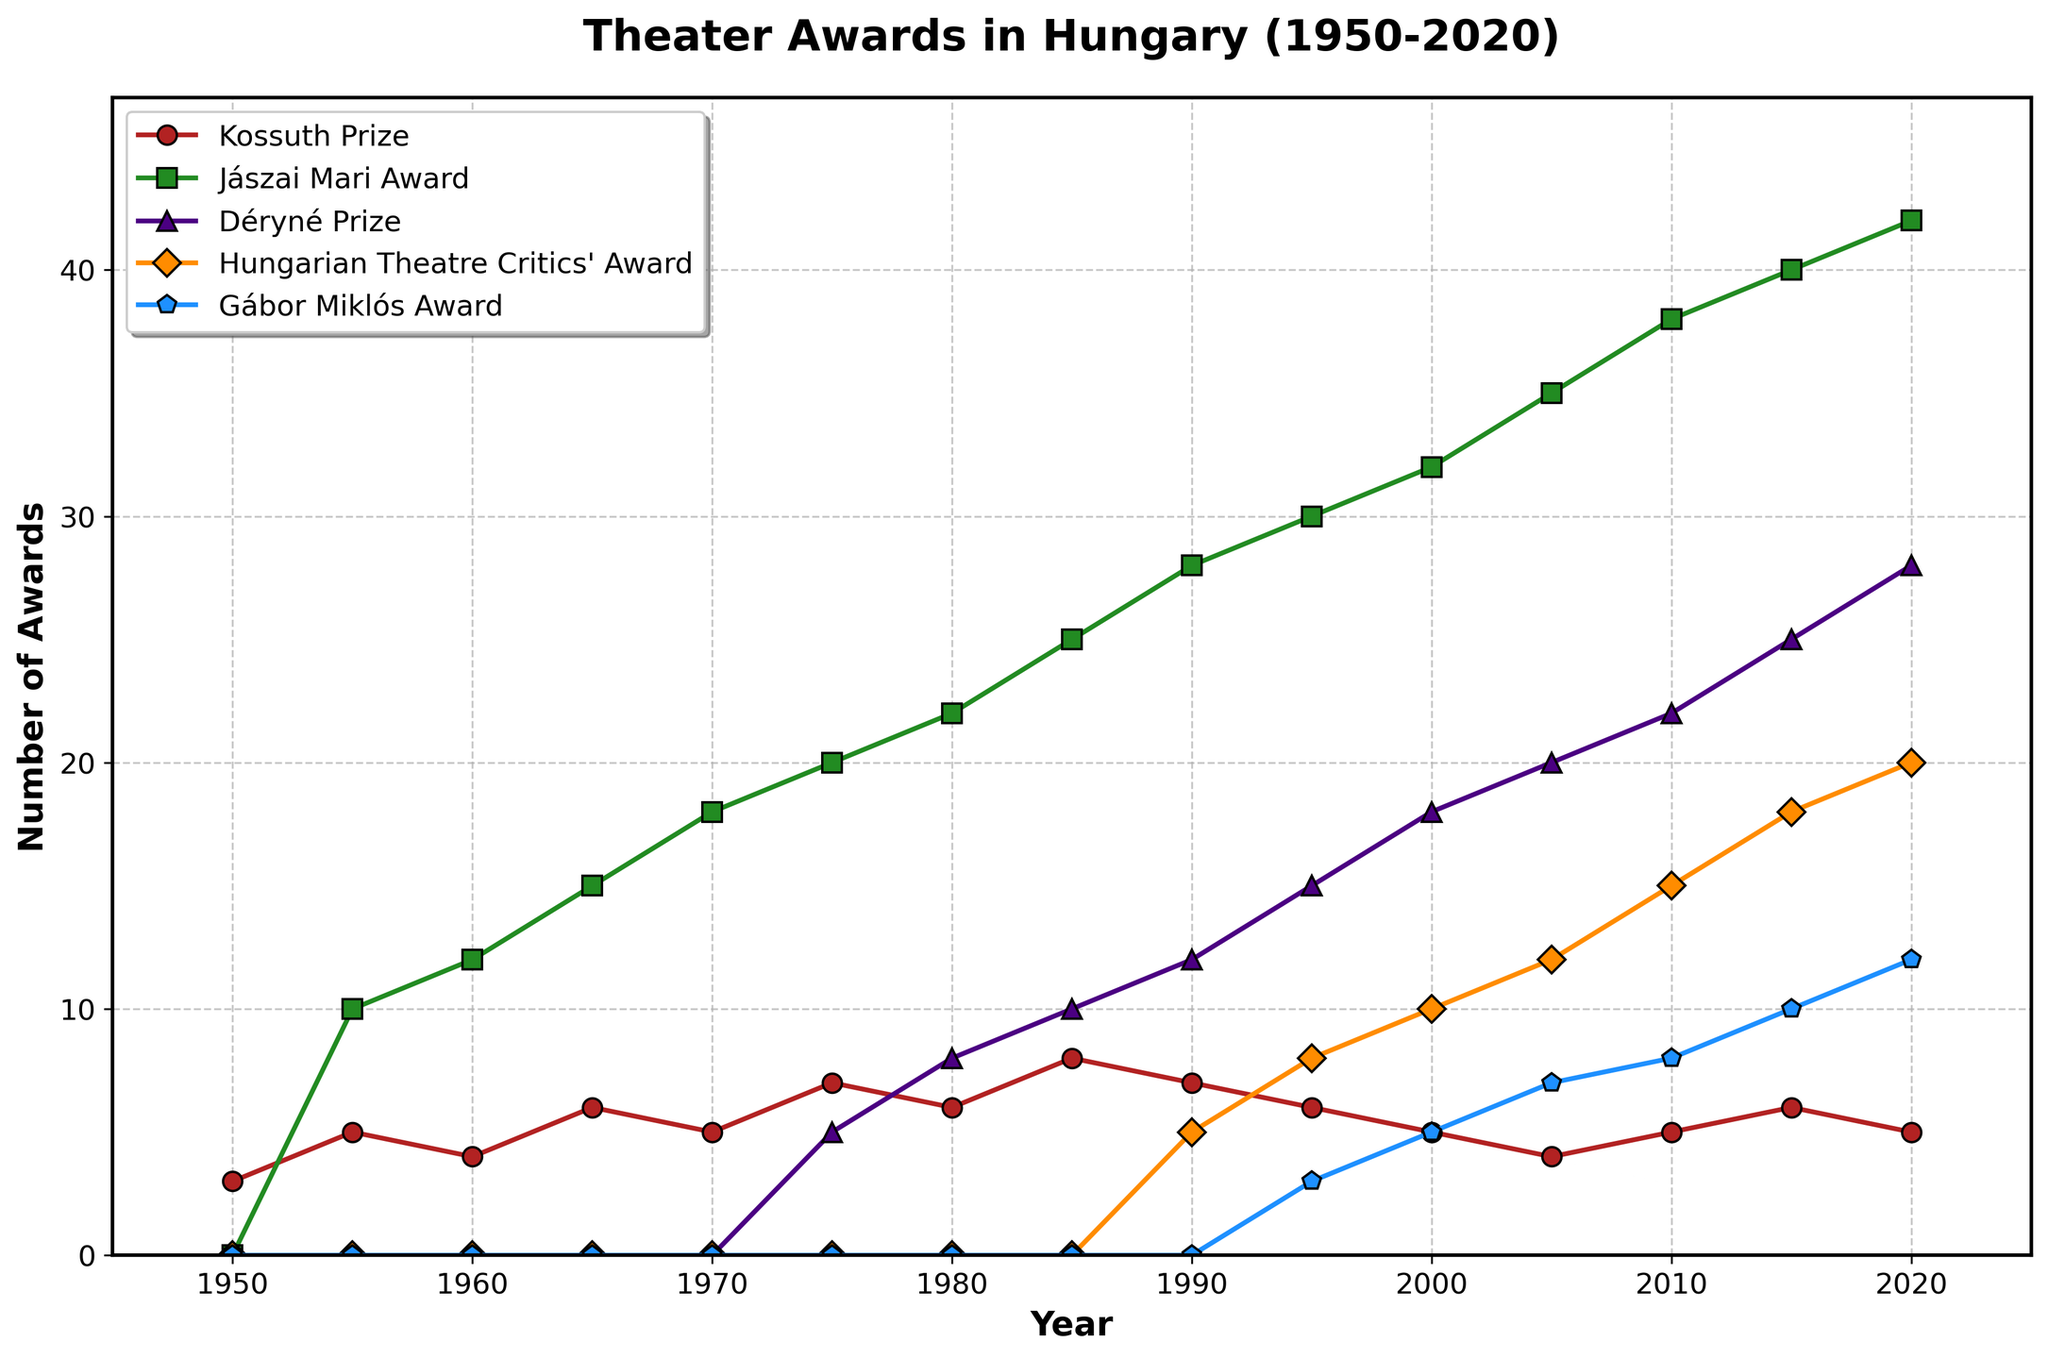What is the highest number of Kossuth Prizes given in a single year? To determine this, look at the line representing the Kossuth Prizes and identify the peak value on the y-axis. In this case, the highest value is reached in 1985 with 8 awards.
Answer: 8 Which award saw the most significant increase in the number of recipients between 1950 and 2020? To answer this, calculate the difference between the numbers in 2020 and 1950 for each award and compare these values. The largest increase is for the Jászai Mari Award, which went from 0 in 1950 to 42 in 2020.
Answer: Jászai Mari Award What year did the Hungarian Theatre Critics' Award start being given, and how many awards were given that year? Look for the first non-zero value for the Hungarian Theatre Critics' Award. In the plot, the award first appears in 1990, with 5 awards given.
Answer: 1990, 5 How many Déryné Prizes in total were awarded between 1975 and 2020? Sum the values of the Déryné Prizes for the years between 1975 and 2020. Adding these values (1975: 5, 1980: 8, 1985: 10, 1990: 12, 1995: 15, 2000: 18, 2005: 20, 2010: 22, 2015: 25, 2020: 28) gives a total of 163.
Answer: 163 Compare the trends of the Jászai Mari Award and the Kossuth Prize over the period. Which one shows a more steady increase? To determine the steadiness, look at the overall shape of both lines. The Jászai Mari Award shows a more consistent, linear increase from 1950 to 2020, while the Kossuth Prize has fluctuations.
Answer: Jászai Mari Award In what time period did the number of Gábor Miklós Awards see the most consistent growth? Look at the slope of the line representing the Gábor Miklós Award. The most consistent growth period is between 1995 and 2020, where it follows a steady upward trend from 0 to 12.
Answer: 1995-2020 What was the total number of awards given in 2015 across all categories? Add the number of awards given in each category for the year 2015 (Kossuth Prize: 6, Jászai Mari Award: 40, Déryné Prize: 25, Hungarian Theatre Critics' Award: 18, Gábor Miklós Award: 10). The total is 99.
Answer: 99 Which award seems to fluctuate the least over the years, indicating more consistent numbers of recipients? To find this, observe the lines on the chart to see which one has the least variation. The Kossuth Prize line fluctuates the least, indicating more consistent numbers of recipients.
Answer: Kossuth Prize How many times more Jászai Mari Awards were given in 2020 compared to 1955? Divide the number of Jászai Mari Awards given in 2020 (42) by the number given in 1955 (10). The result is 4.2 times.
Answer: 4.2 